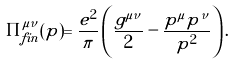<formula> <loc_0><loc_0><loc_500><loc_500>\Pi _ { f i n } ^ { \mu \nu } ( p ) = \frac { e ^ { 2 } } { \pi } \left ( \frac { g ^ { \mu \nu } } { 2 } - \frac { p ^ { \mu } p ^ { \nu } } { p ^ { 2 } } \right ) .</formula> 